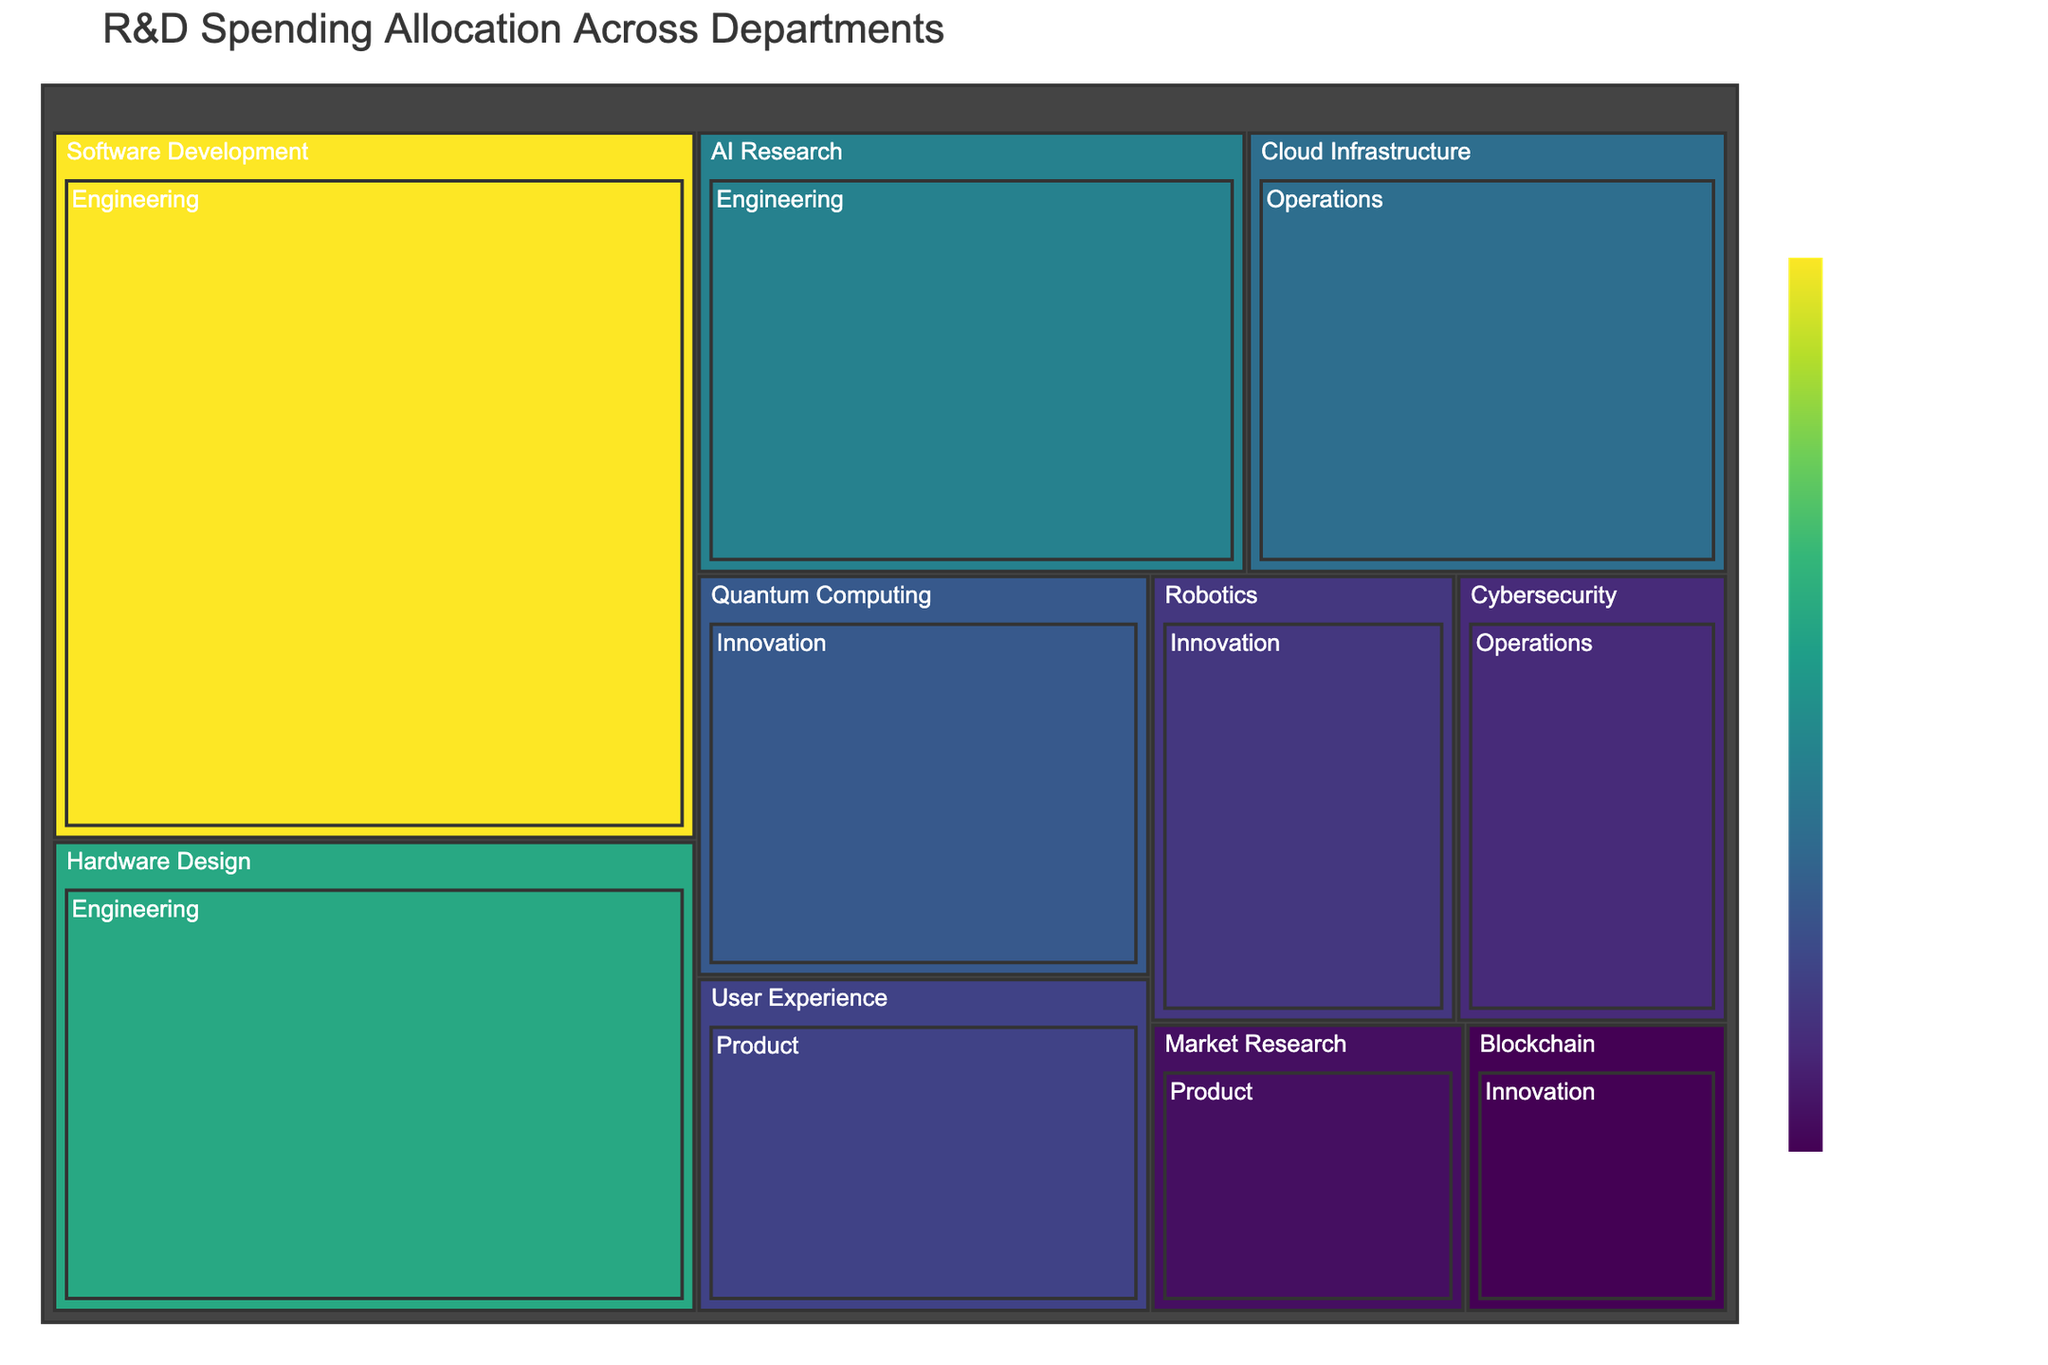What is the title of the treemap? The title of the treemap is typically displayed at the top of the figure.
Answer: R&D Spending Allocation Across Departments Which category and department have the highest spending? By looking at the largest block in the treemap and checking its label, you can identify the category and department with the highest spending. This block corresponds to "Software Development" in the "Engineering" department, which is the largest in size.
Answer: Software Development, Engineering How much is the total spending for the Innovation department? To find the total spending for Innovation, sum the spending amounts of its subcategories: Quantum Computing ($60,000,000), Robotics ($45,000,000), and Blockchain ($25,000,000). Summing these amounts: $60,000,000 + $45,000,000 + $25,000,000 = $130,000,000.
Answer: $130,000,000 Compare the spending between AI Research and User Experience. Which has more and by how much? Check the spending values for AI Research ($80,000,000) and User Experience ($50,000,000). Subtract the smaller amount from the larger amount to find the difference: $80,000,000 - $50,000,000 = $30,000,000.
Answer: AI Research by $30,000,000 What is the smallest spending category and how much is allocated to it? Locate the smallest block in the treemap, which represents the category with the smallest spending. The smallest category is "Blockchain" with $25,000,000 allocated to it.
Answer: Blockchain, $25,000,000 Which department has the most evenly distributed funding across its categories? Compare the size and relative proportions of the blocks within each department. Operations has two categories, Cloud Infrastructure ($70,000,000) and Cybersecurity ($40,000,000), which are fairly balanced compared to other departments.
Answer: Operations How much more is spent on Cloud Infrastructure compared to Market Research? Find the spending on Cloud Infrastructure ($70,000,000) and Market Research ($30,000,000). Subtract the smaller amount from the larger amount to find the difference: $70,000,000 - $30,000,000 = $40,000,000.
Answer: $40,000,000 Among the Engineering subcategories, which one has the least amount of spending and what is the amount? Within the Engineering department, compare the spending on Software Development ($150,000,000), Hardware Design ($100,000,000), and AI Research ($80,000,000) to identify the smallest amount. The least spending is on AI Research with $80,000,000.
Answer: AI Research, $80,000,000 Determine the ratio of spending between Engineering and Product departments. Sum up the spending in Engineering (Software Development: $150,000,000, Hardware Design: $100,000,000, AI Research: $80,000,000) resulting in $330,000,000, and in Product (User Experience: $50,000,000, Market Research: $30,000,000) resulting in $80,000,000. The ratio is $330,000,000:$80,000,000, which simplifies to approximately 4.125:1.
Answer: 4.125:1 Identify the category in the Innovation department with the highest spending. Within Innovation, compare the spending on Quantum Computing ($60,000,000), Robotics ($45,000,000), and Blockchain ($25,000,000). The highest spending is on Quantum Computing.
Answer: Quantum Computing 